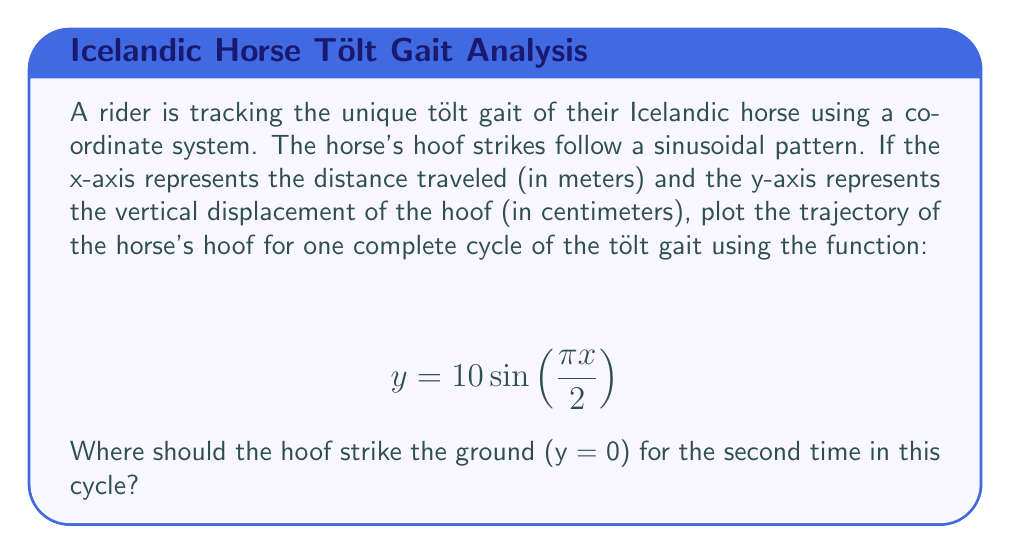Solve this math problem. To solve this problem, we need to follow these steps:

1) First, let's understand what the equation represents:
   $$ y = 10 \sin\left(\frac{\pi x}{2}\right) $$
   Here, 10 is the amplitude (maximum vertical displacement in cm), and $\frac{\pi}{2}$ is the frequency of the sine wave.

2) The hoof strikes the ground when y = 0. So we need to solve:
   $$ 0 = 10 \sin\left(\frac{\pi x}{2}\right) $$

3) This equation is satisfied when $\sin\left(\frac{\pi x}{2}\right) = 0$

4) We know that sine equals zero when its argument is a multiple of π:
   $$ \frac{\pi x}{2} = n\pi, \text{ where } n \text{ is an integer} $$

5) Solving for x:
   $$ x = 2n $$

6) The first strike occurs at x = 0 (when n = 0)
   The second strike occurs at x = 2 (when n = 1)
   The third strike occurs at x = 4 (when n = 2)

7) We're asked for the second time the hoof strikes the ground, which corresponds to x = 4 meters.

[asy]
import graph;
size(300,200);
real f(real x) {return 10*sin(pi*x/2);}
xaxis("x (meters)",Ticks());
yaxis("y (cm)",Ticks());
draw(graph(f,0,4));
dot((4,0),red);
label("(4,0)",(4,0),SE,red);
[/asy]
Answer: The horse's hoof will strike the ground for the second time at x = 4 meters. 